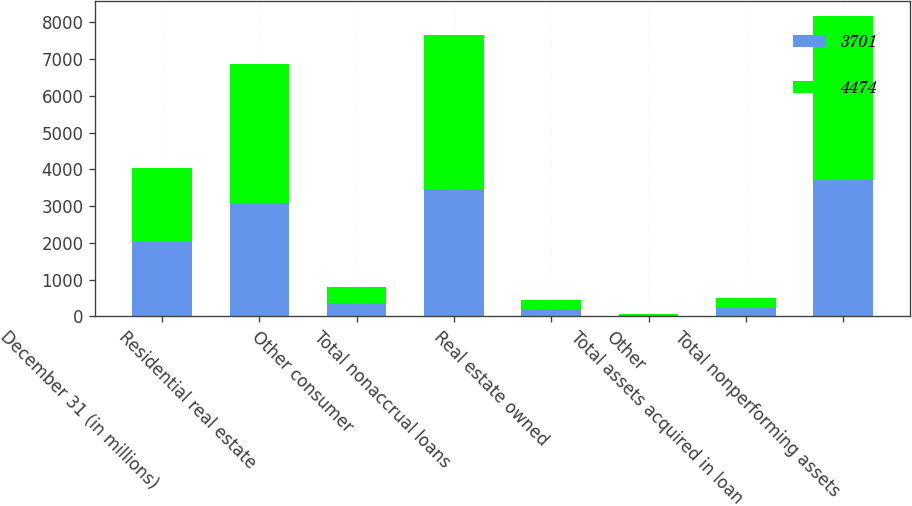Convert chart. <chart><loc_0><loc_0><loc_500><loc_500><stacked_bar_chart><ecel><fcel>December 31 (in millions)<fcel>Residential real estate<fcel>Other consumer<fcel>Total nonaccrual loans<fcel>Real estate owned<fcel>Other<fcel>Total assets acquired in loan<fcel>Total nonperforming assets<nl><fcel>3701<fcel>2018<fcel>3088<fcel>373<fcel>3461<fcel>210<fcel>30<fcel>240<fcel>3701<nl><fcel>4474<fcel>2017<fcel>3785<fcel>424<fcel>4209<fcel>225<fcel>40<fcel>265<fcel>4474<nl></chart> 